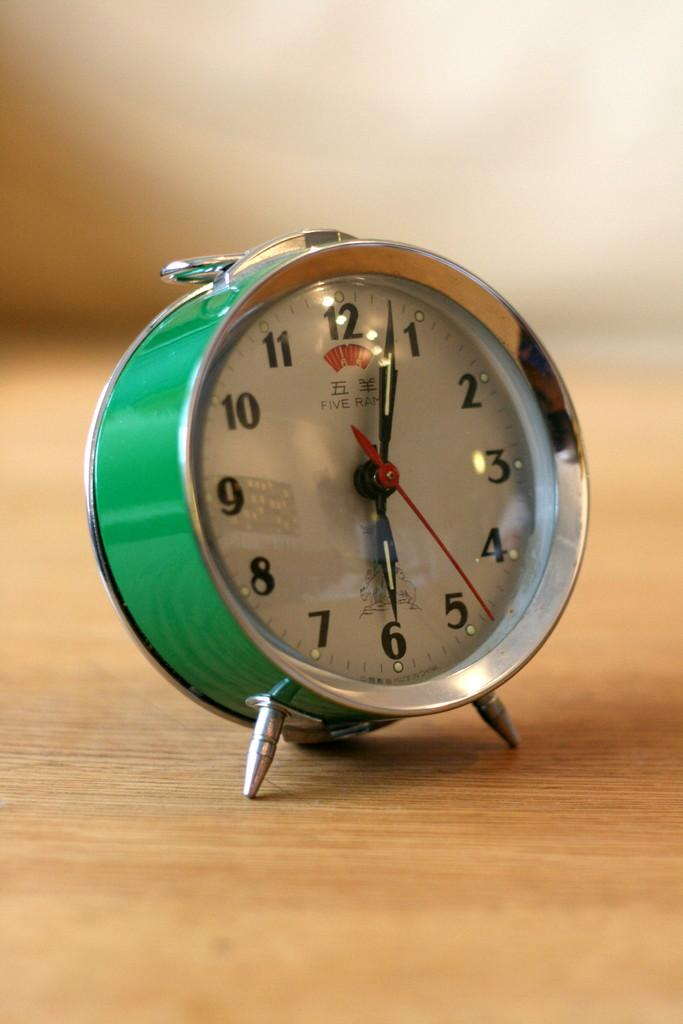<image>
Offer a succinct explanation of the picture presented. The clock's hands show that the time is a few minutes passed six o'clock. 